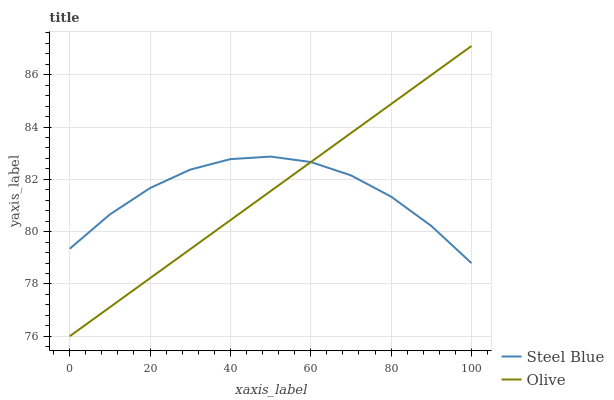Does Olive have the minimum area under the curve?
Answer yes or no. Yes. Does Steel Blue have the maximum area under the curve?
Answer yes or no. Yes. Does Steel Blue have the minimum area under the curve?
Answer yes or no. No. Is Olive the smoothest?
Answer yes or no. Yes. Is Steel Blue the roughest?
Answer yes or no. Yes. Is Steel Blue the smoothest?
Answer yes or no. No. Does Olive have the lowest value?
Answer yes or no. Yes. Does Steel Blue have the lowest value?
Answer yes or no. No. Does Olive have the highest value?
Answer yes or no. Yes. Does Steel Blue have the highest value?
Answer yes or no. No. Does Olive intersect Steel Blue?
Answer yes or no. Yes. Is Olive less than Steel Blue?
Answer yes or no. No. Is Olive greater than Steel Blue?
Answer yes or no. No. 